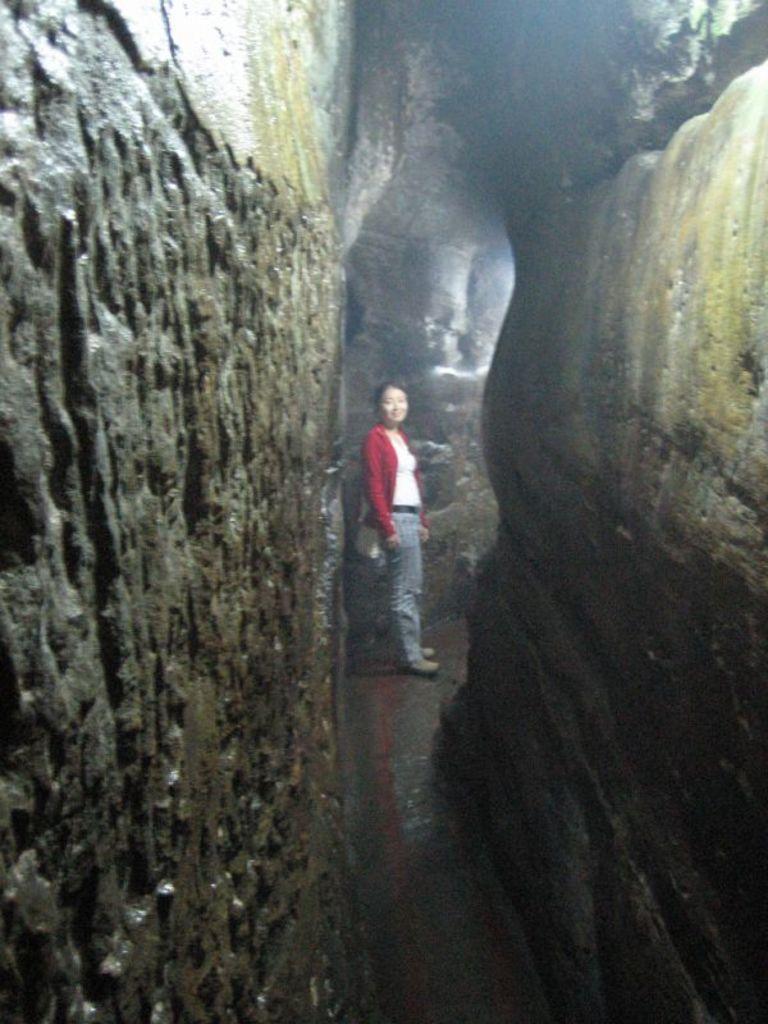Please provide a concise description of this image. In this picture, there is a cave. In the center, there is a woman wearing a white top, red shrug and a blue jeans. 